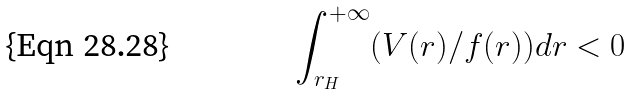Convert formula to latex. <formula><loc_0><loc_0><loc_500><loc_500>\int _ { r _ { H } } ^ { + \infty } ( V ( r ) / f ( r ) ) d r < 0</formula> 